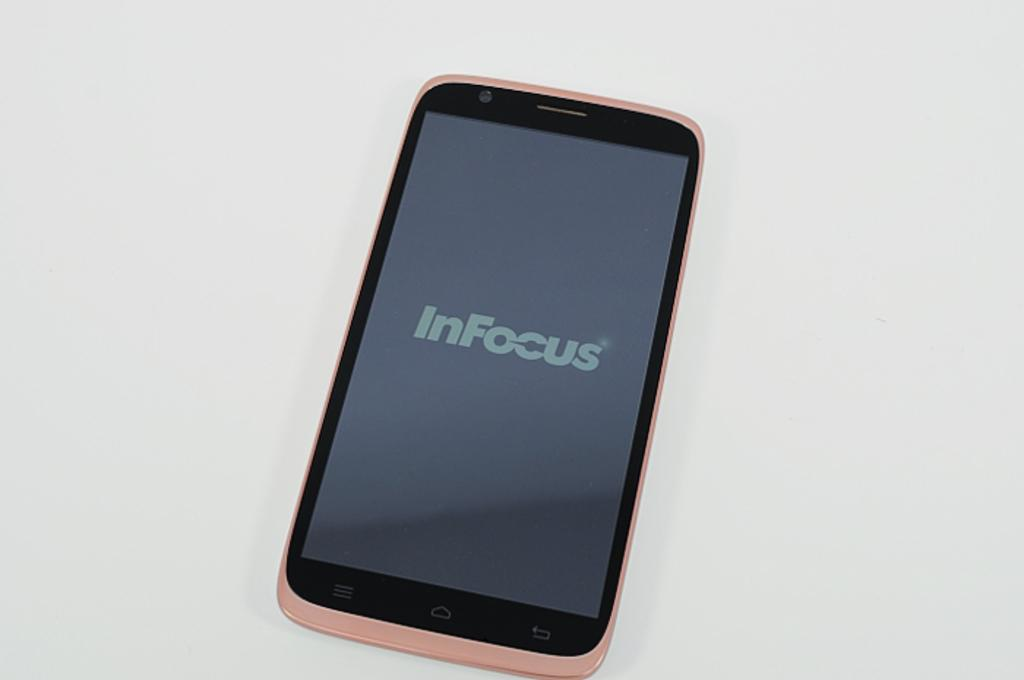<image>
Create a compact narrative representing the image presented. a phone that has the word InFocus on the front 